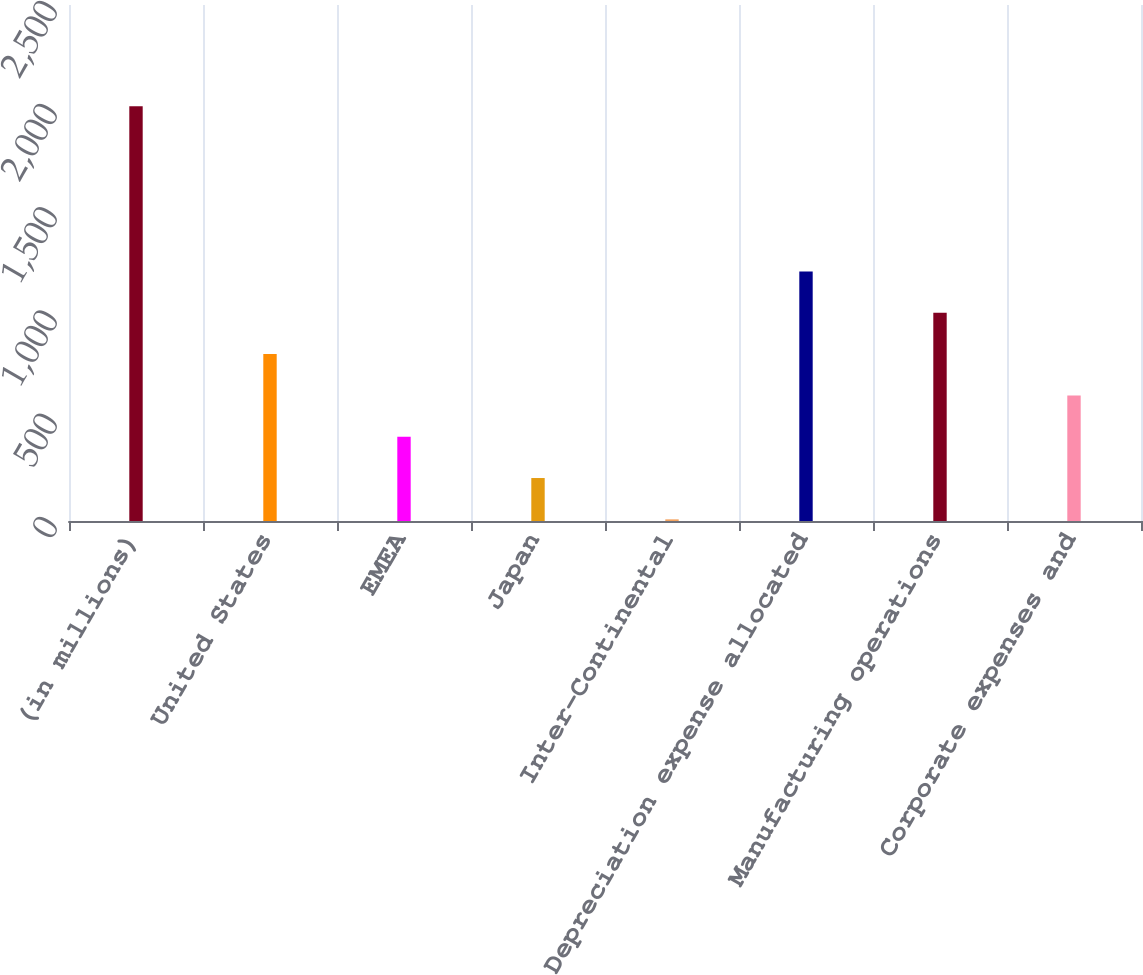<chart> <loc_0><loc_0><loc_500><loc_500><bar_chart><fcel>(in millions)<fcel>United States<fcel>EMEA<fcel>Japan<fcel>Inter-Continental<fcel>Depreciation expense allocated<fcel>Manufacturing operations<fcel>Corporate expenses and<nl><fcel>2010<fcel>808.8<fcel>408.4<fcel>208.2<fcel>8<fcel>1209.2<fcel>1009<fcel>608.6<nl></chart> 